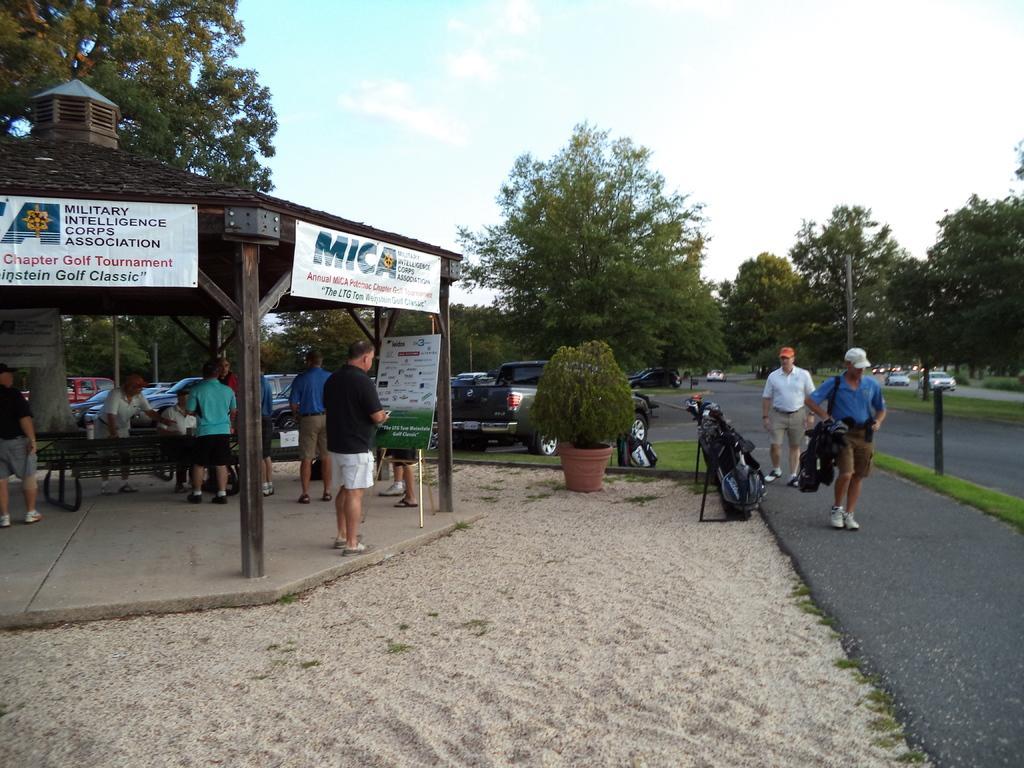How would you summarize this image in a sentence or two? In this picture we can see some people, shed, sand, posters, plant, vehicles, trees, some objects and in the background we can see the sky. 